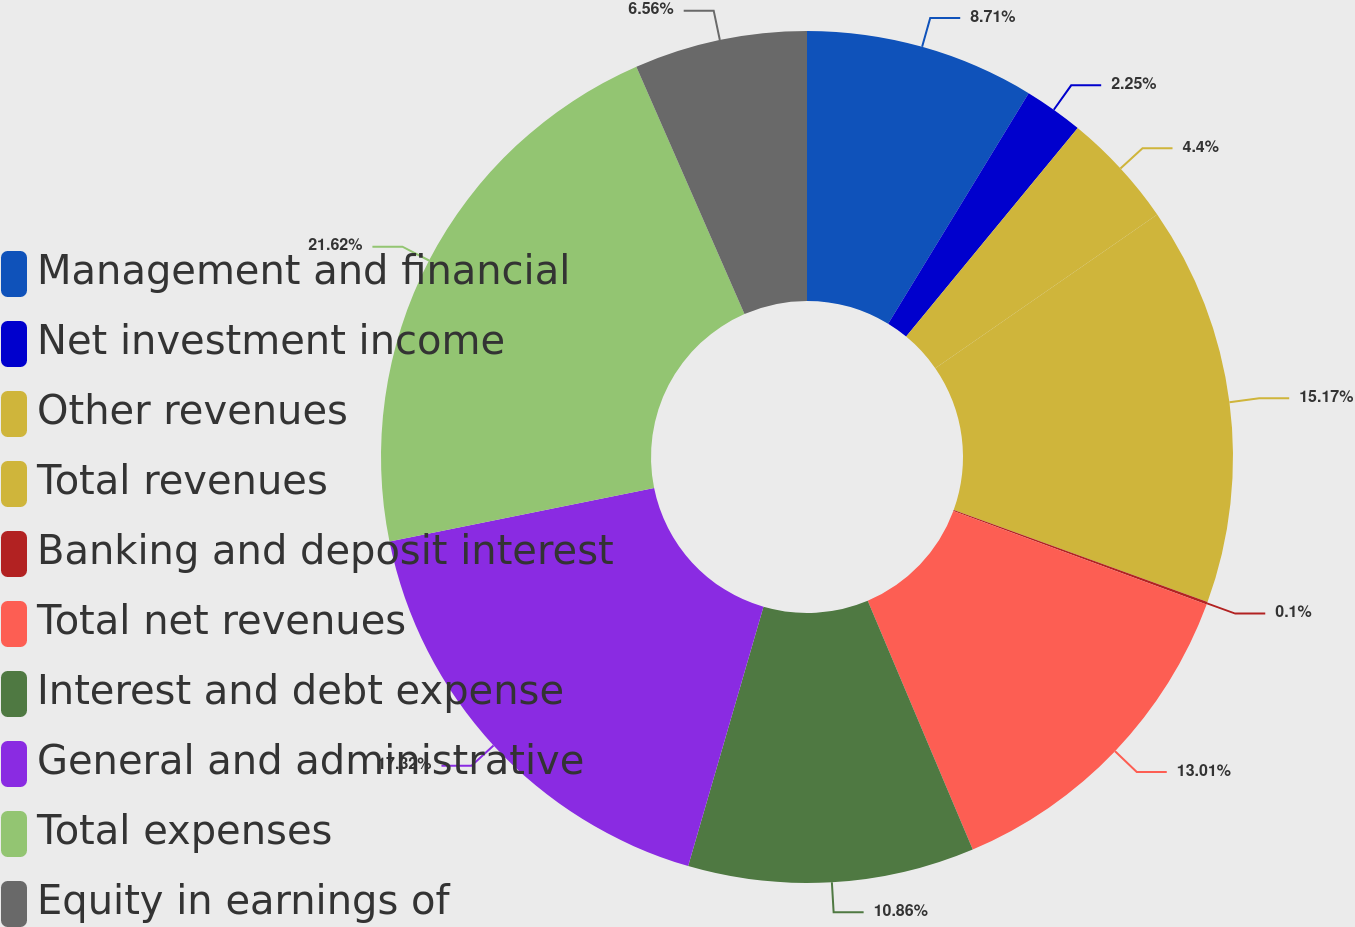Convert chart. <chart><loc_0><loc_0><loc_500><loc_500><pie_chart><fcel>Management and financial<fcel>Net investment income<fcel>Other revenues<fcel>Total revenues<fcel>Banking and deposit interest<fcel>Total net revenues<fcel>Interest and debt expense<fcel>General and administrative<fcel>Total expenses<fcel>Equity in earnings of<nl><fcel>8.71%<fcel>2.25%<fcel>4.4%<fcel>15.17%<fcel>0.1%<fcel>13.01%<fcel>10.86%<fcel>17.32%<fcel>21.62%<fcel>6.56%<nl></chart> 